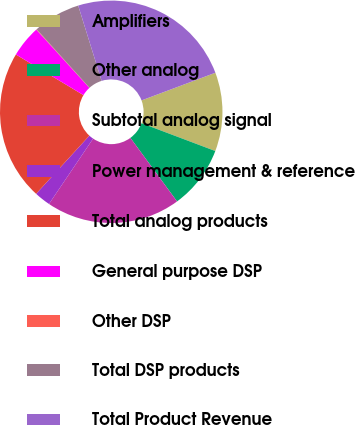Convert chart to OTSL. <chart><loc_0><loc_0><loc_500><loc_500><pie_chart><fcel>Amplifiers<fcel>Other analog<fcel>Subtotal analog signal<fcel>Power management & reference<fcel>Total analog products<fcel>General purpose DSP<fcel>Other DSP<fcel>Total DSP products<fcel>Total Product Revenue<nl><fcel>11.45%<fcel>9.18%<fcel>19.53%<fcel>2.35%<fcel>21.81%<fcel>4.62%<fcel>0.07%<fcel>6.9%<fcel>24.09%<nl></chart> 